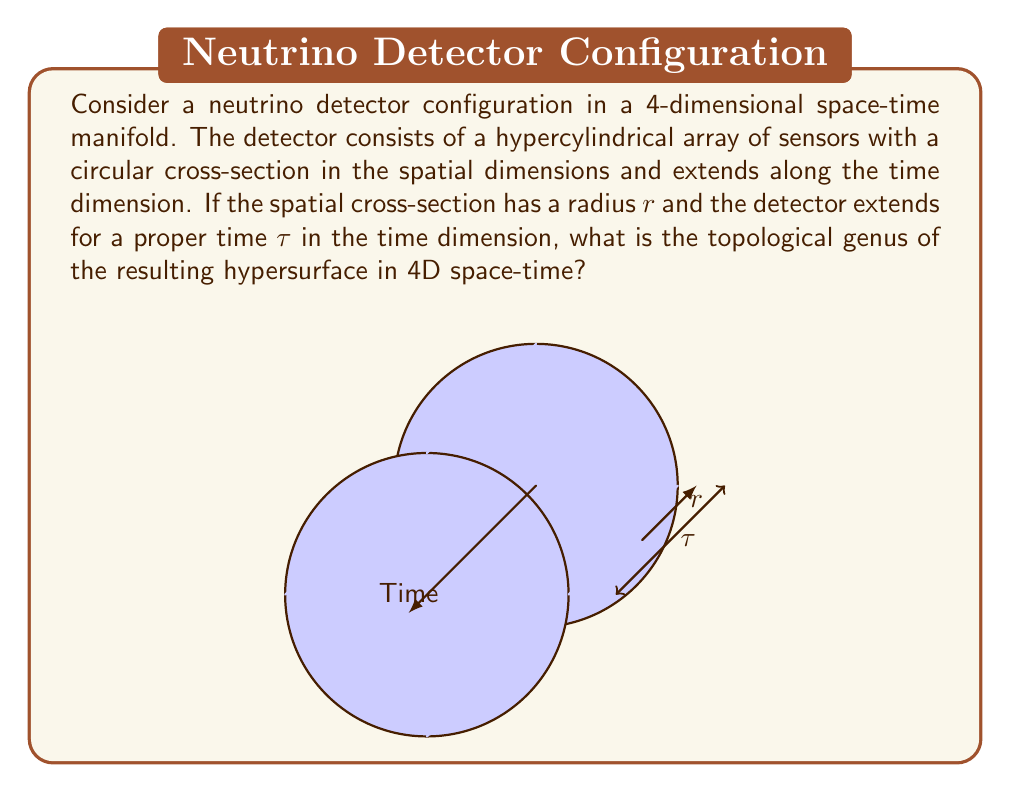Could you help me with this problem? To determine the topological genus of the hypersurface, we need to analyze its structure in 4D space-time:

1) In the spatial dimensions, we have a circular cross-section. This forms a 2-dimensional surface (S²).

2) The detector extends along the time dimension, forming a cylinder-like structure in 4D. This can be thought of as the Cartesian product of S² and an interval I: S² × I.

3) In topology, the genus of a surface is the number of handles it has. For higher-dimensional manifolds, we consider the generalization of this concept.

4) The topological structure of our hypercylinder is equivalent to S² × S¹, where S¹ represents the circular nature of proper time in relativistic physics (assuming a closed time-like curve).

5) The Cartesian product of spheres does not introduce any new "handles" or holes in the topology.

6) The genus of S² is 0 (a sphere has no handles), and the genus of S¹ is also 0 (a circle has no handles).

7) When taking the Cartesian product of manifolds, the resulting genus is the sum of the genera of the individual manifolds.

Therefore, the genus of our 4D hypersurface is:

$$g = g(S²) + g(S¹) = 0 + 0 = 0$$

The hypersurface, despite its complex 4D structure, is topologically equivalent to a 3-sphere (S³) embedded in 4D space-time, which has a genus of 0.
Answer: 0 